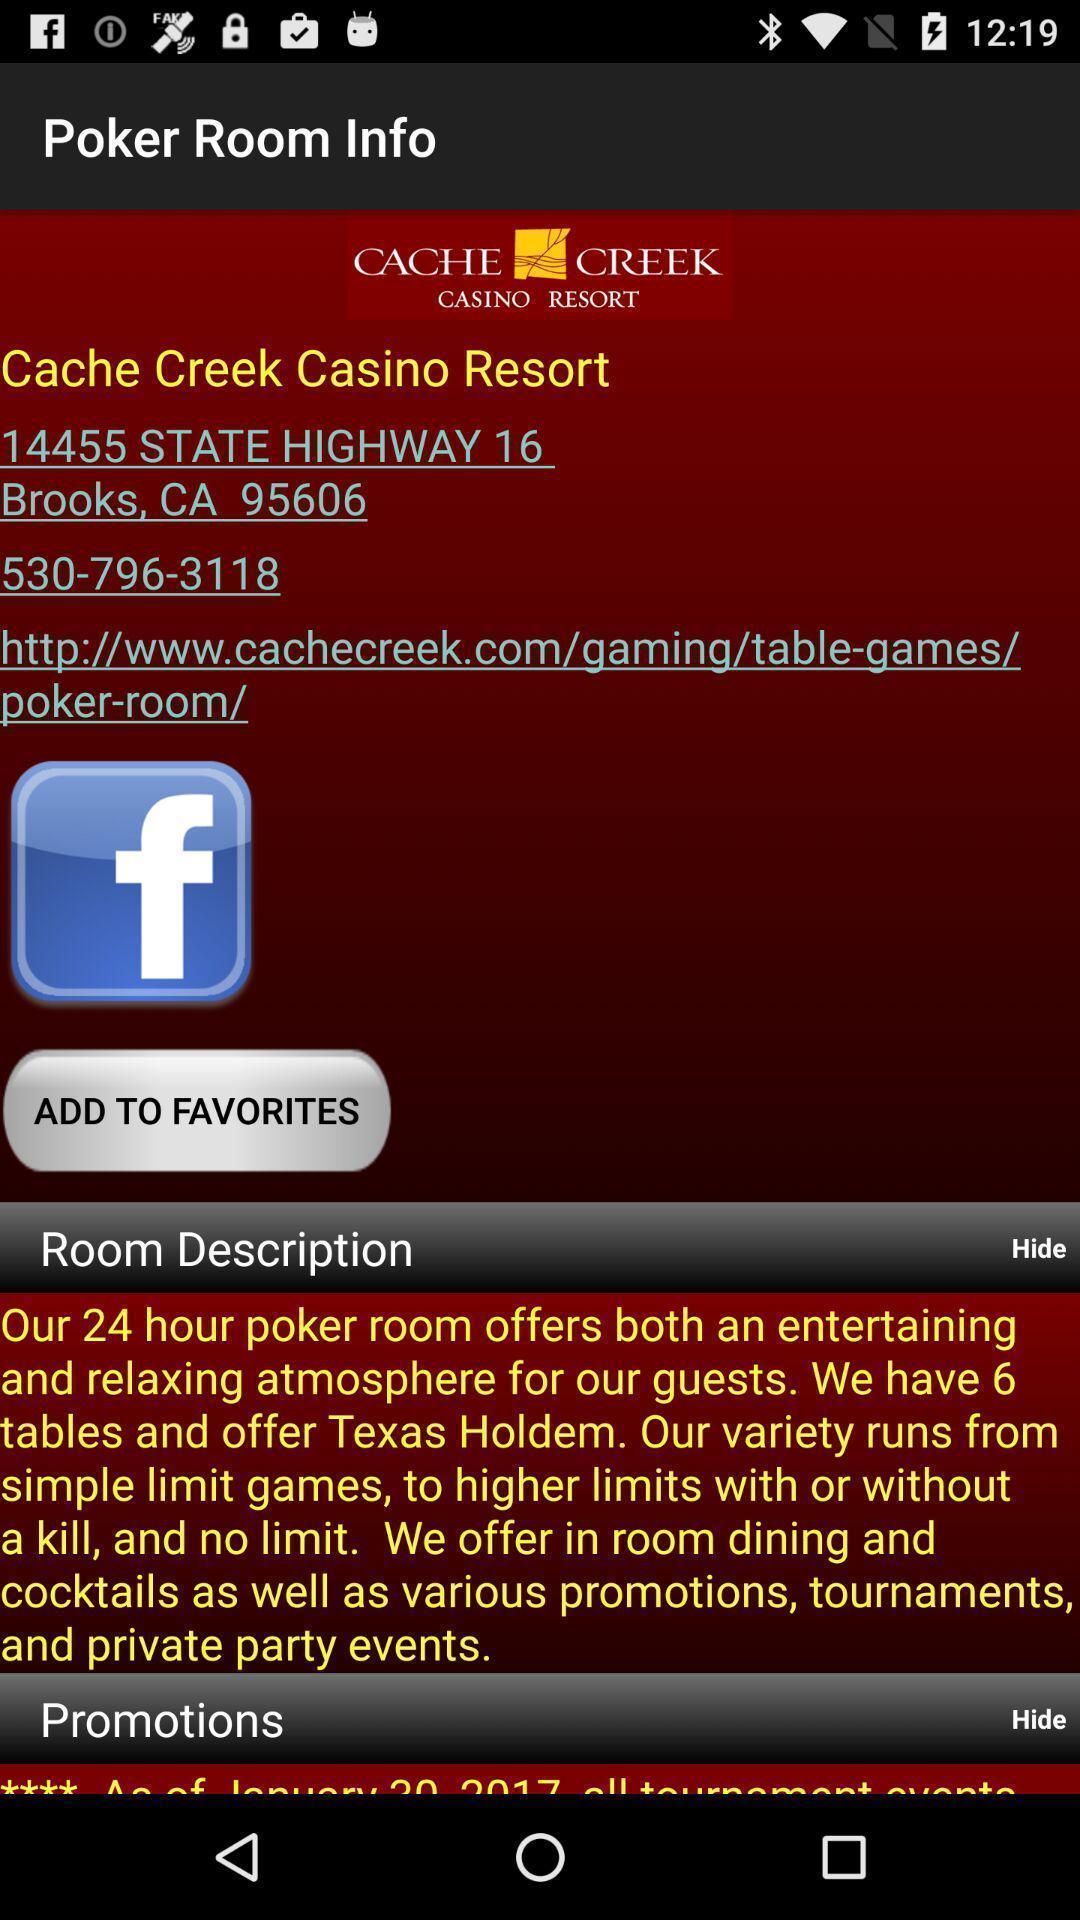What is the overall content of this screenshot? Page of a poker app with its description. 